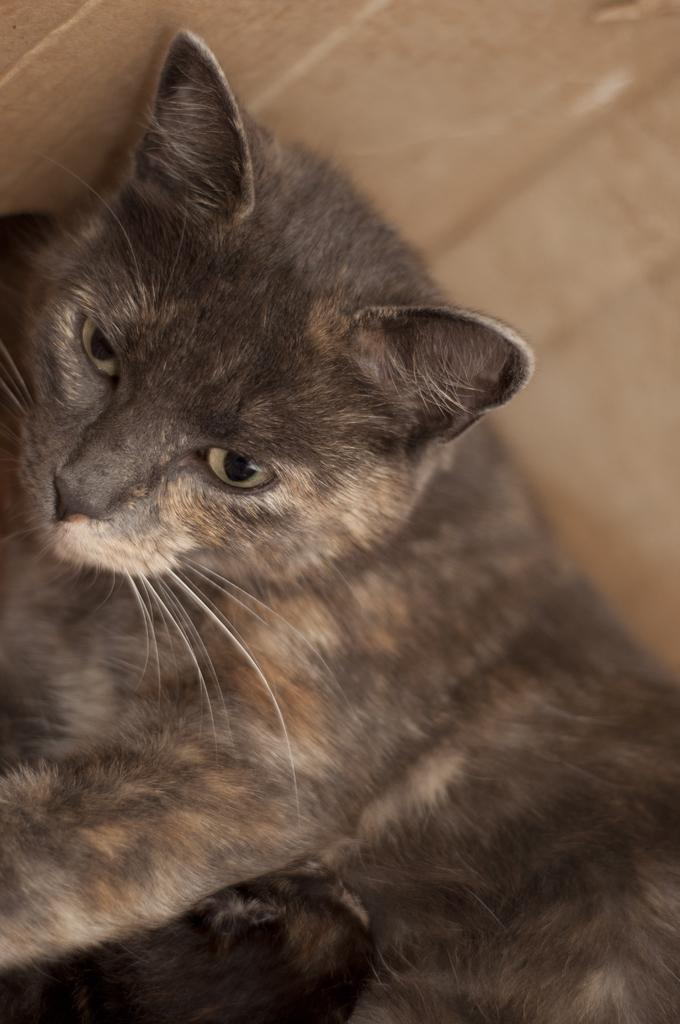What type of animal is present in the image? There is a cat in the image. Can you describe the color of the cat? The cat is black in color. How many rabbits are sitting on the pie in the image? There are no rabbits or pies present in the image; it features a black cat. 